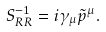<formula> <loc_0><loc_0><loc_500><loc_500>S ^ { - 1 } _ { R R } = i \gamma _ { \mu } \tilde { p } ^ { \mu } .</formula> 